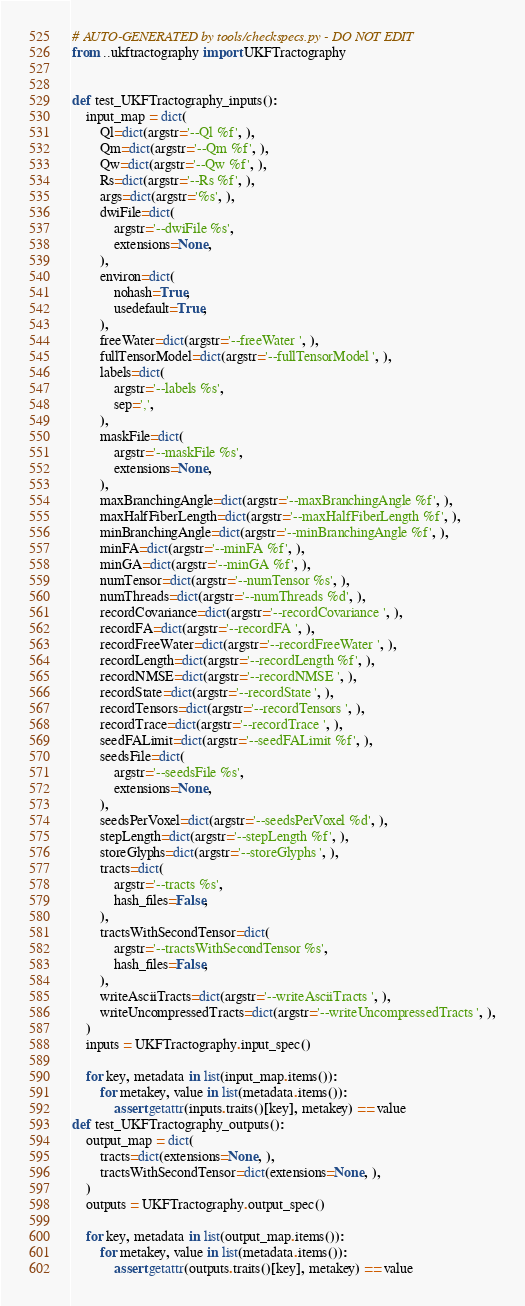<code> <loc_0><loc_0><loc_500><loc_500><_Python_># AUTO-GENERATED by tools/checkspecs.py - DO NOT EDIT
from ..ukftractography import UKFTractography


def test_UKFTractography_inputs():
    input_map = dict(
        Ql=dict(argstr='--Ql %f', ),
        Qm=dict(argstr='--Qm %f', ),
        Qw=dict(argstr='--Qw %f', ),
        Rs=dict(argstr='--Rs %f', ),
        args=dict(argstr='%s', ),
        dwiFile=dict(
            argstr='--dwiFile %s',
            extensions=None,
        ),
        environ=dict(
            nohash=True,
            usedefault=True,
        ),
        freeWater=dict(argstr='--freeWater ', ),
        fullTensorModel=dict(argstr='--fullTensorModel ', ),
        labels=dict(
            argstr='--labels %s',
            sep=',',
        ),
        maskFile=dict(
            argstr='--maskFile %s',
            extensions=None,
        ),
        maxBranchingAngle=dict(argstr='--maxBranchingAngle %f', ),
        maxHalfFiberLength=dict(argstr='--maxHalfFiberLength %f', ),
        minBranchingAngle=dict(argstr='--minBranchingAngle %f', ),
        minFA=dict(argstr='--minFA %f', ),
        minGA=dict(argstr='--minGA %f', ),
        numTensor=dict(argstr='--numTensor %s', ),
        numThreads=dict(argstr='--numThreads %d', ),
        recordCovariance=dict(argstr='--recordCovariance ', ),
        recordFA=dict(argstr='--recordFA ', ),
        recordFreeWater=dict(argstr='--recordFreeWater ', ),
        recordLength=dict(argstr='--recordLength %f', ),
        recordNMSE=dict(argstr='--recordNMSE ', ),
        recordState=dict(argstr='--recordState ', ),
        recordTensors=dict(argstr='--recordTensors ', ),
        recordTrace=dict(argstr='--recordTrace ', ),
        seedFALimit=dict(argstr='--seedFALimit %f', ),
        seedsFile=dict(
            argstr='--seedsFile %s',
            extensions=None,
        ),
        seedsPerVoxel=dict(argstr='--seedsPerVoxel %d', ),
        stepLength=dict(argstr='--stepLength %f', ),
        storeGlyphs=dict(argstr='--storeGlyphs ', ),
        tracts=dict(
            argstr='--tracts %s',
            hash_files=False,
        ),
        tractsWithSecondTensor=dict(
            argstr='--tractsWithSecondTensor %s',
            hash_files=False,
        ),
        writeAsciiTracts=dict(argstr='--writeAsciiTracts ', ),
        writeUncompressedTracts=dict(argstr='--writeUncompressedTracts ', ),
    )
    inputs = UKFTractography.input_spec()

    for key, metadata in list(input_map.items()):
        for metakey, value in list(metadata.items()):
            assert getattr(inputs.traits()[key], metakey) == value
def test_UKFTractography_outputs():
    output_map = dict(
        tracts=dict(extensions=None, ),
        tractsWithSecondTensor=dict(extensions=None, ),
    )
    outputs = UKFTractography.output_spec()

    for key, metadata in list(output_map.items()):
        for metakey, value in list(metadata.items()):
            assert getattr(outputs.traits()[key], metakey) == value
</code> 